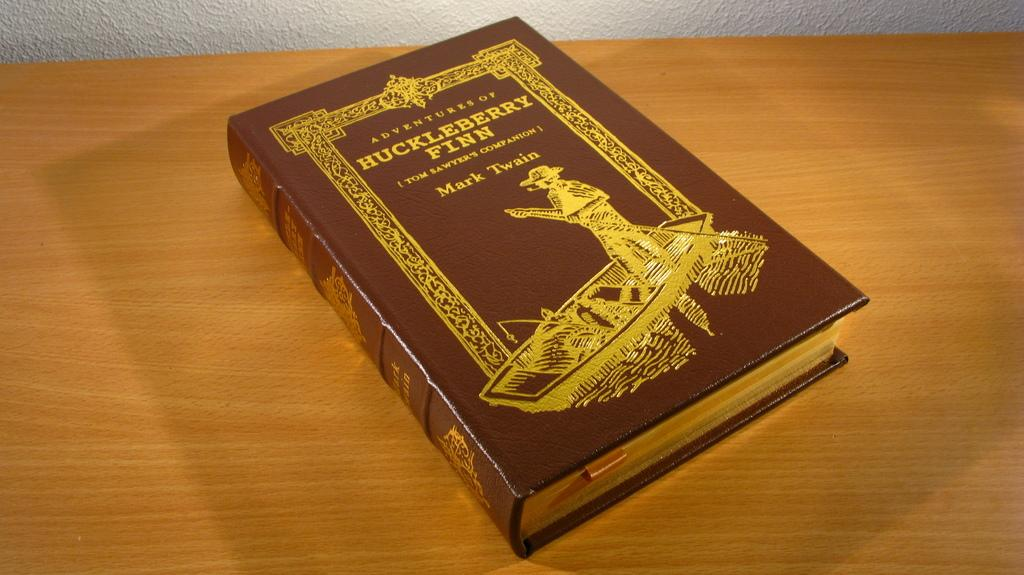<image>
Give a short and clear explanation of the subsequent image. The famous book sittin gon the table was written by Mark Twain. 